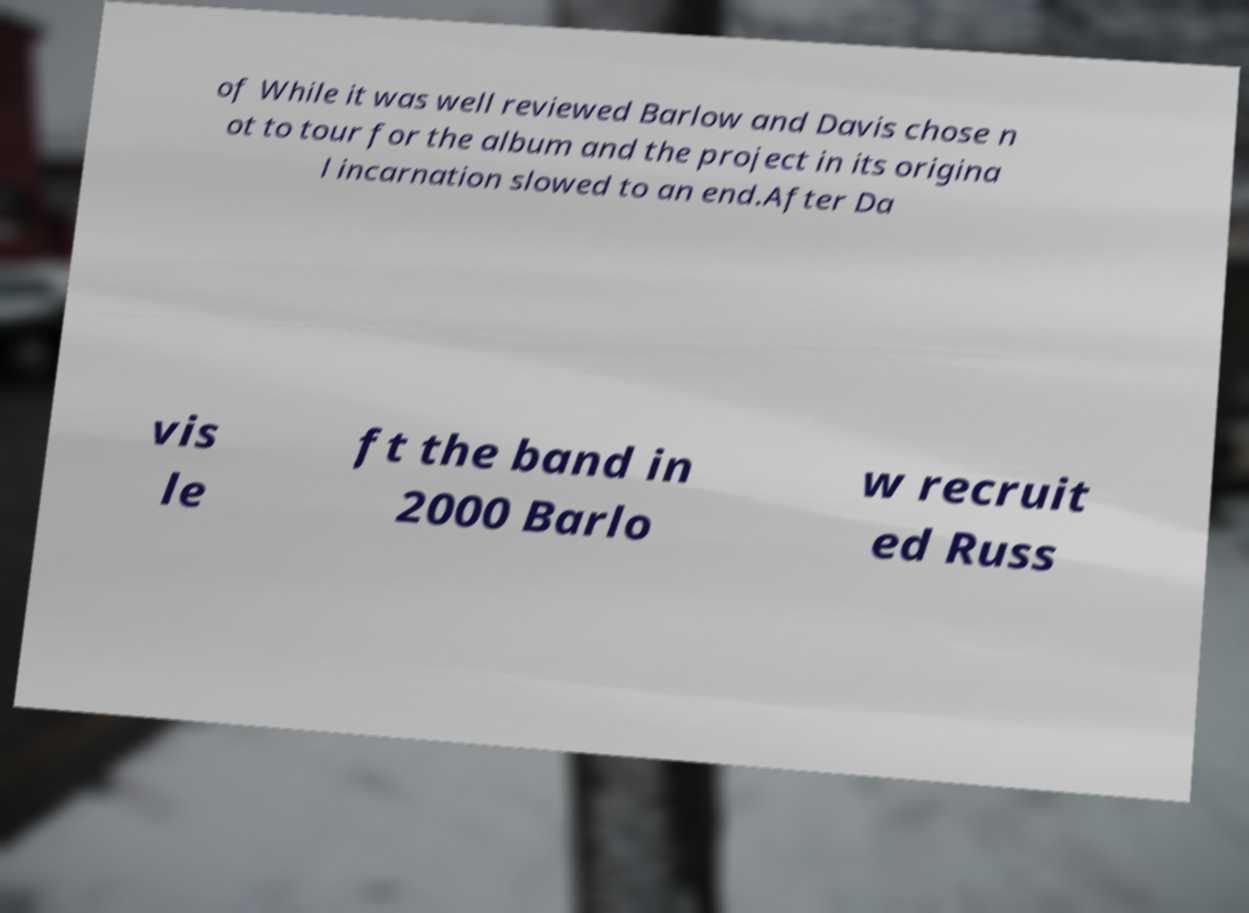Can you read and provide the text displayed in the image?This photo seems to have some interesting text. Can you extract and type it out for me? of While it was well reviewed Barlow and Davis chose n ot to tour for the album and the project in its origina l incarnation slowed to an end.After Da vis le ft the band in 2000 Barlo w recruit ed Russ 